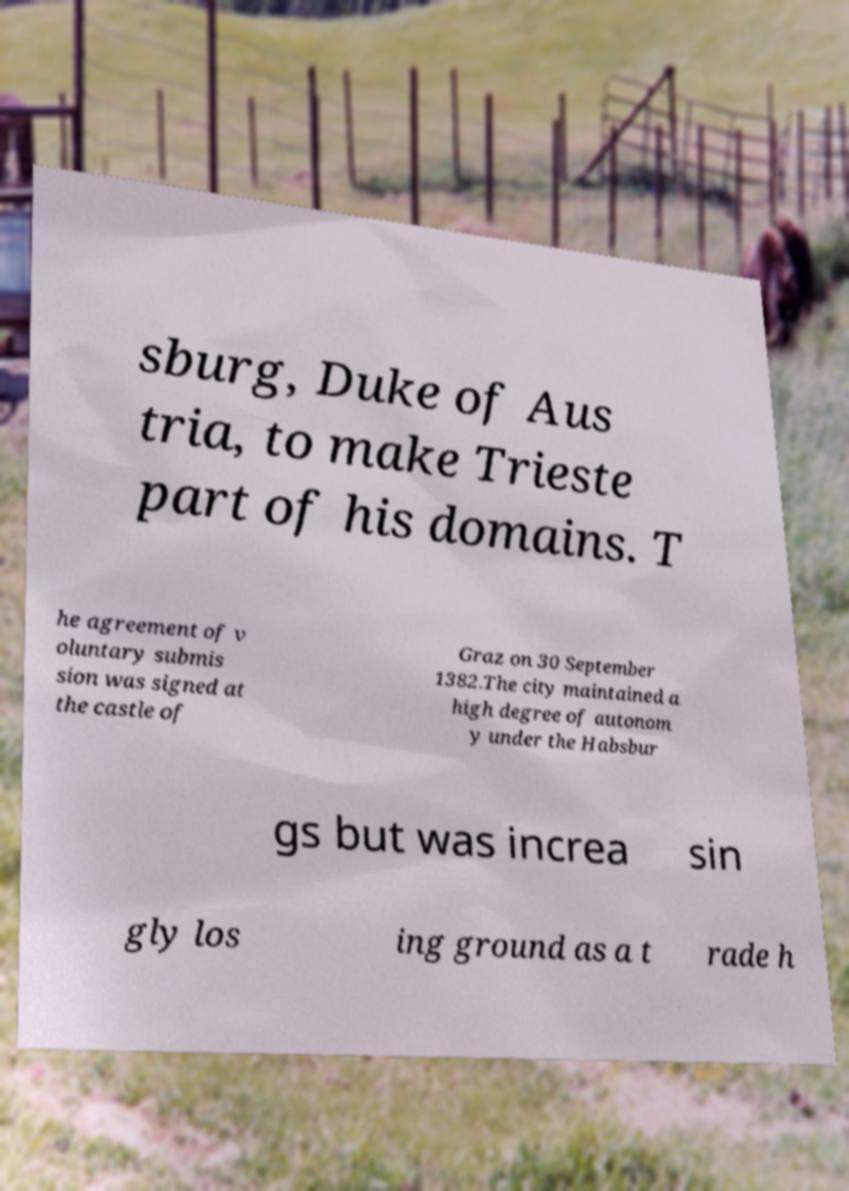Can you accurately transcribe the text from the provided image for me? sburg, Duke of Aus tria, to make Trieste part of his domains. T he agreement of v oluntary submis sion was signed at the castle of Graz on 30 September 1382.The city maintained a high degree of autonom y under the Habsbur gs but was increa sin gly los ing ground as a t rade h 